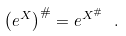Convert formula to latex. <formula><loc_0><loc_0><loc_500><loc_500>\left ( e ^ { X } \right ) ^ { \# } = e ^ { X ^ { \# } } \ .</formula> 